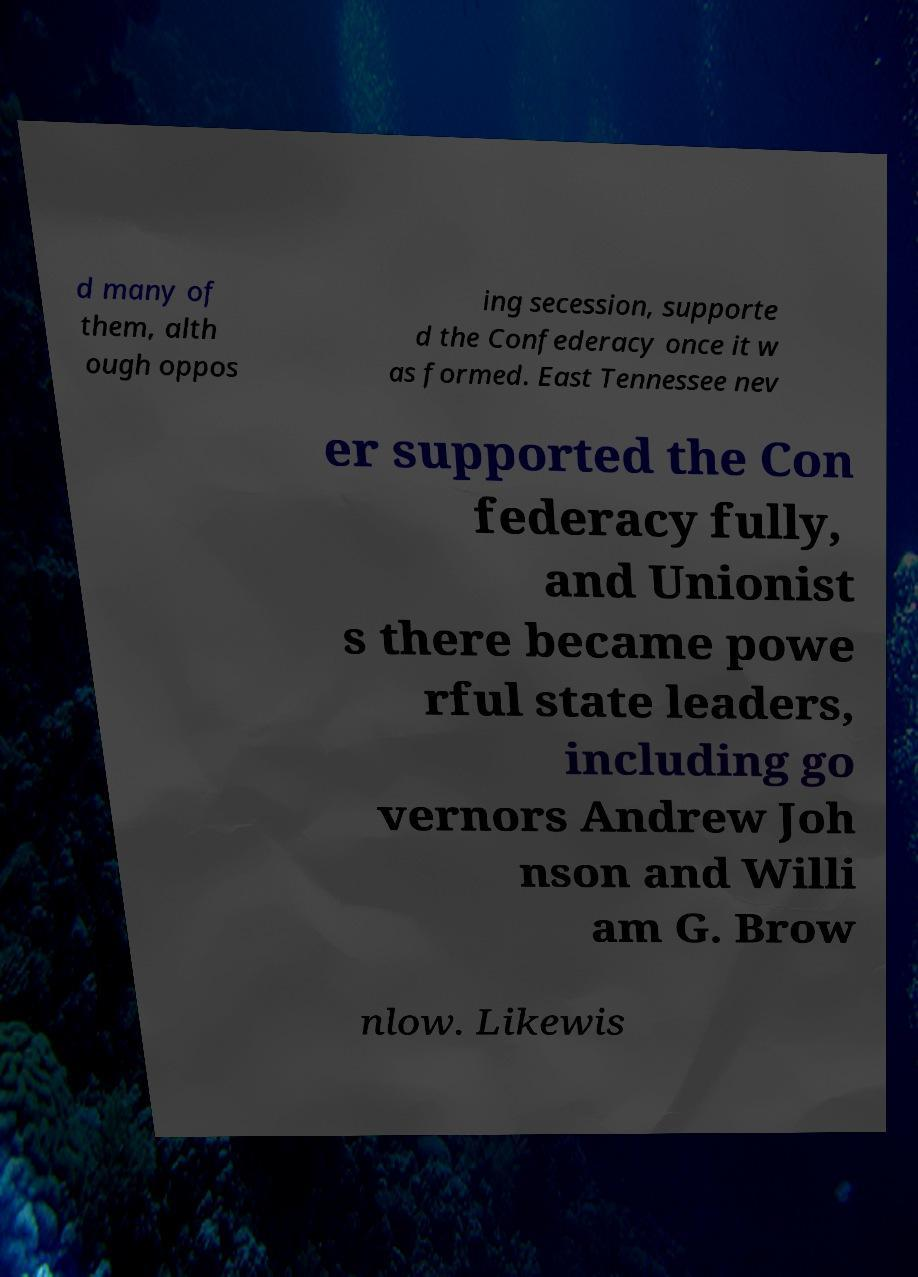I need the written content from this picture converted into text. Can you do that? d many of them, alth ough oppos ing secession, supporte d the Confederacy once it w as formed. East Tennessee nev er supported the Con federacy fully, and Unionist s there became powe rful state leaders, including go vernors Andrew Joh nson and Willi am G. Brow nlow. Likewis 